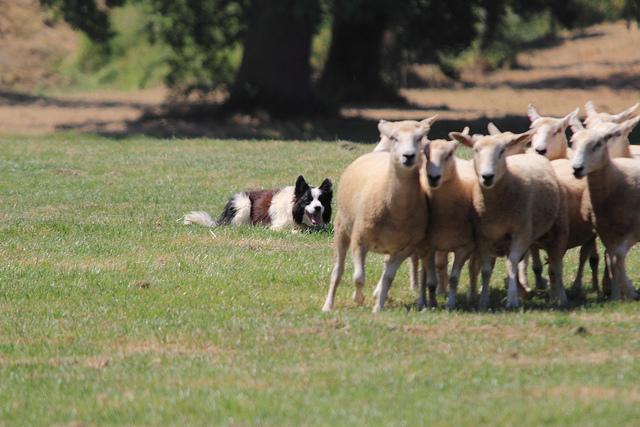Does the dog like the sheep?
Short answer required. Yes. How many sheeps are this?
Quick response, please. 6. What kind of dog is that?
Answer briefly. Shepherd. Are there 8 sheep?
Quick response, please. No. Is the dog doing its job?
Concise answer only. Yes. 